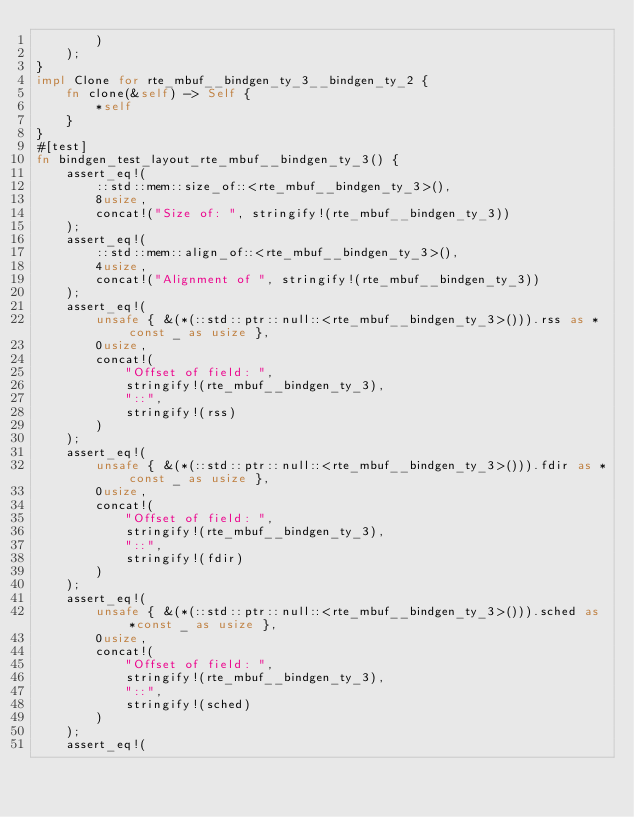Convert code to text. <code><loc_0><loc_0><loc_500><loc_500><_Rust_>        )
    );
}
impl Clone for rte_mbuf__bindgen_ty_3__bindgen_ty_2 {
    fn clone(&self) -> Self {
        *self
    }
}
#[test]
fn bindgen_test_layout_rte_mbuf__bindgen_ty_3() {
    assert_eq!(
        ::std::mem::size_of::<rte_mbuf__bindgen_ty_3>(),
        8usize,
        concat!("Size of: ", stringify!(rte_mbuf__bindgen_ty_3))
    );
    assert_eq!(
        ::std::mem::align_of::<rte_mbuf__bindgen_ty_3>(),
        4usize,
        concat!("Alignment of ", stringify!(rte_mbuf__bindgen_ty_3))
    );
    assert_eq!(
        unsafe { &(*(::std::ptr::null::<rte_mbuf__bindgen_ty_3>())).rss as *const _ as usize },
        0usize,
        concat!(
            "Offset of field: ",
            stringify!(rte_mbuf__bindgen_ty_3),
            "::",
            stringify!(rss)
        )
    );
    assert_eq!(
        unsafe { &(*(::std::ptr::null::<rte_mbuf__bindgen_ty_3>())).fdir as *const _ as usize },
        0usize,
        concat!(
            "Offset of field: ",
            stringify!(rte_mbuf__bindgen_ty_3),
            "::",
            stringify!(fdir)
        )
    );
    assert_eq!(
        unsafe { &(*(::std::ptr::null::<rte_mbuf__bindgen_ty_3>())).sched as *const _ as usize },
        0usize,
        concat!(
            "Offset of field: ",
            stringify!(rte_mbuf__bindgen_ty_3),
            "::",
            stringify!(sched)
        )
    );
    assert_eq!(</code> 